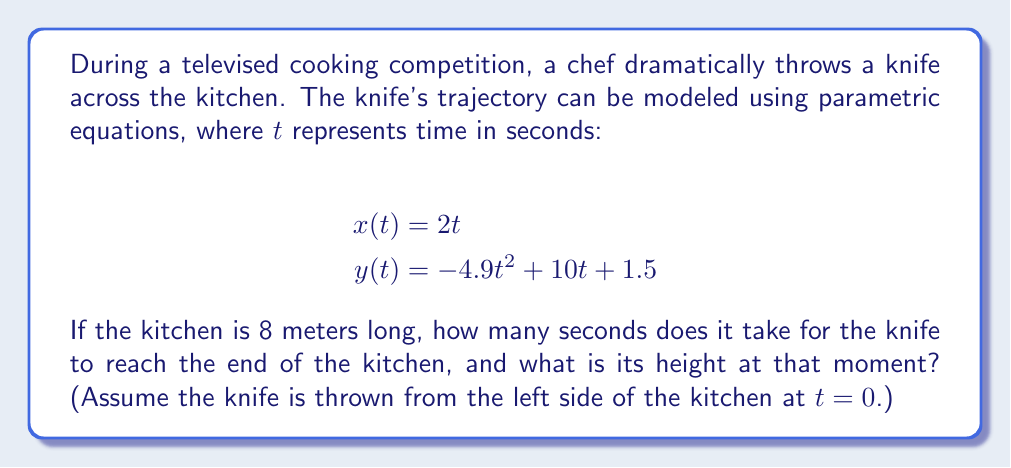Provide a solution to this math problem. Let's approach this problem step by step:

1) First, we need to find when the knife reaches the end of the kitchen. We know the kitchen is 8 meters long, so we need to solve:

   $$x(t) = 8$$
   $$2t = 8$$
   $$t = 4$$

   So it takes 4 seconds for the knife to reach the end of the kitchen.

2) Now that we know the time, we can calculate the height of the knife at this moment by plugging $t=4$ into the equation for $y(t)$:

   $$y(4) = -4.9(4)^2 + 10(4) + 1.5$$
   $$= -4.9(16) + 40 + 1.5$$
   $$= -78.4 + 40 + 1.5$$
   $$= -36.9 + 1.5$$
   $$= -35.4$$

3) However, a negative height doesn't make sense in this context. The knife has hit the ground before reaching the end of the kitchen.

4) To find when the knife hits the ground, we need to solve:

   $$y(t) = 0$$
   $$-4.9t^2 + 10t + 1.5 = 0$$

   This is a quadratic equation. We can solve it using the quadratic formula:
   $$t = \frac{-b \pm \sqrt{b^2 - 4ac}}{2a}$$

   Where $a=-4.9$, $b=10$, and $c=1.5$

   $$t = \frac{-10 \pm \sqrt{100 - 4(-4.9)(1.5)}}{2(-4.9)}$$
   $$= \frac{-10 \pm \sqrt{100 + 29.4}}{-9.8}$$
   $$= \frac{-10 \pm \sqrt{129.4}}{-9.8}$$
   $$= \frac{-10 \pm 11.38}{-9.8}$$

   This gives us two solutions: $t \approx 0.14$ or $t \approx 2.18$

   The second solution, 2.18 seconds, is the time when the knife hits the ground.

5) At this time, the horizontal distance traveled is:

   $$x(2.18) = 2(2.18) = 4.36$$ meters

Therefore, the knife never reaches the end of the 8-meter kitchen. It hits the ground after about 2.18 seconds at a distance of about 4.36 meters.
Answer: The knife does not reach the end of the kitchen. It hits the ground after approximately 2.18 seconds at a distance of about 4.36 meters from its starting point. 